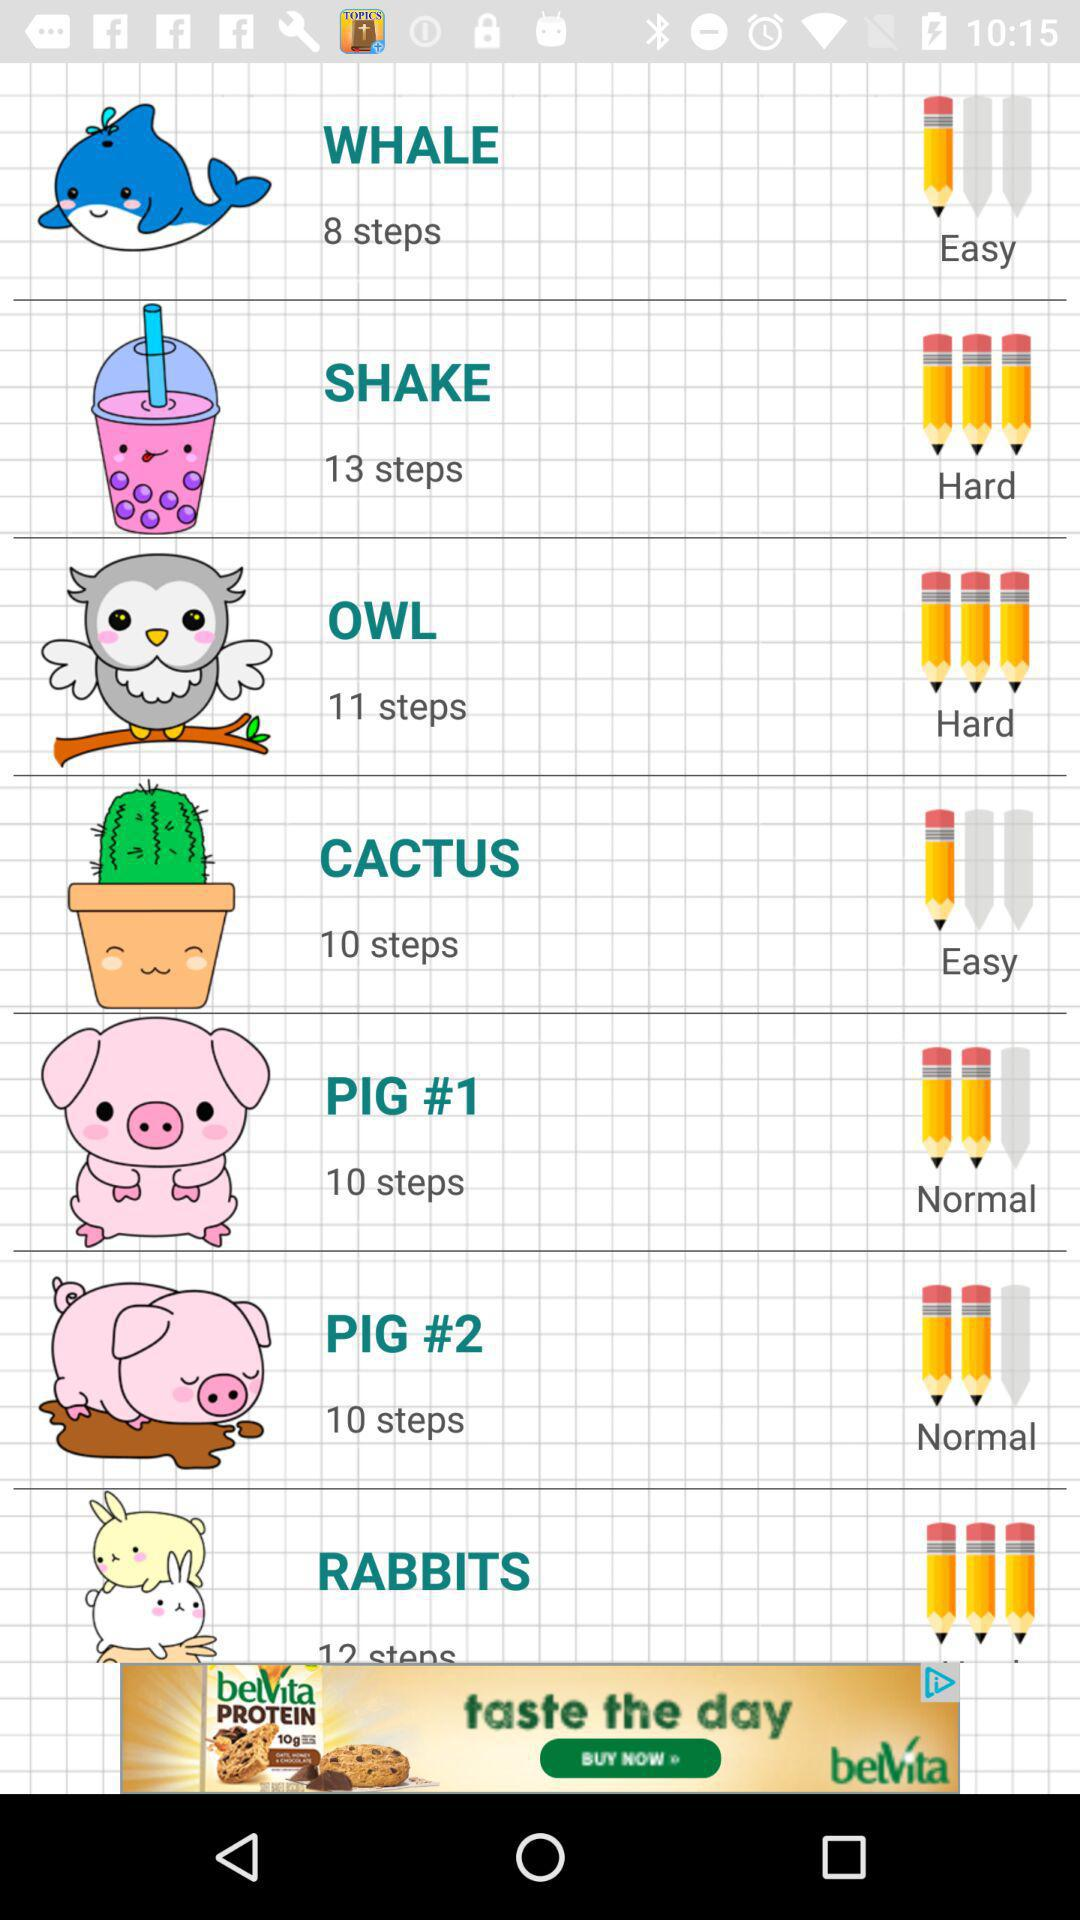Is "SHAKE" easy or hard? The "SHAKE" is hard. 